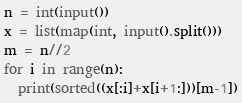<code> <loc_0><loc_0><loc_500><loc_500><_Python_>n = int(input())
x = list(map(int, input().split()))
m = n//2
for i in range(n):
  print(sorted((x[:i]+x[i+1:]))[m-1])</code> 